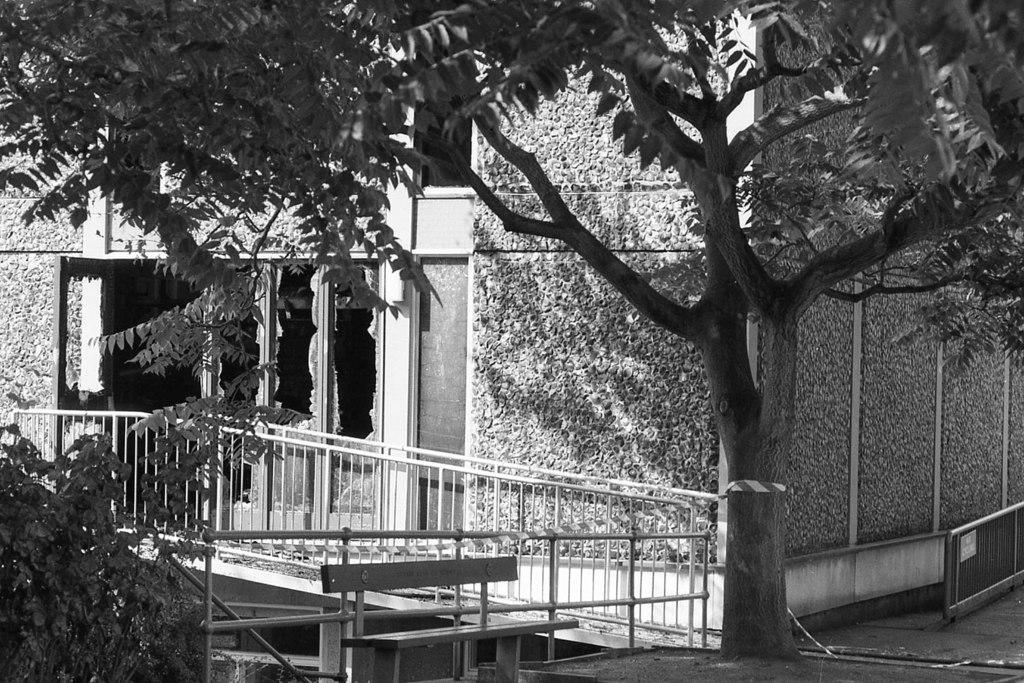What type of vegetation is visible in the front of the image? There are trees in the front of the image. What can be seen in the front of the image besides the trees? There is a railing in the front of the image. What type of structure is visible in the background of the image? There is a building in the background of the image. What is your opinion on the addition of more trees in the image? The provided facts do not mention any opinions or suggestions for adding more trees. The image itself only shows the existing trees, railing, and building. 